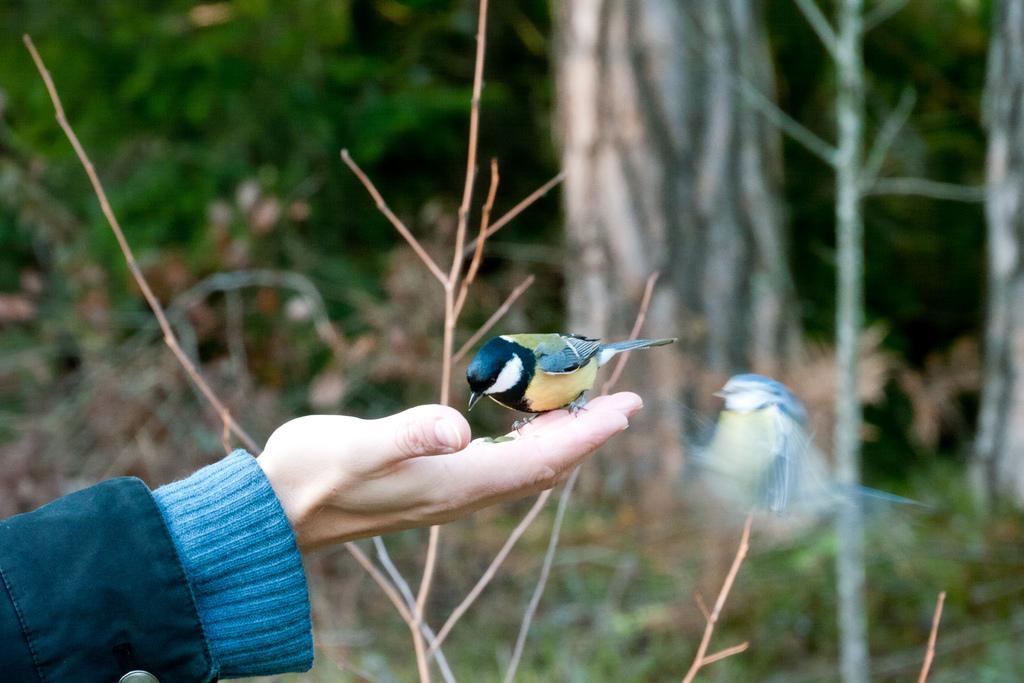Could you give a brief overview of what you see in this image? In this image we can see a bird on the person's hand and there is another bird flying in the air at the hand. In the background we can see bare plants and trees. 